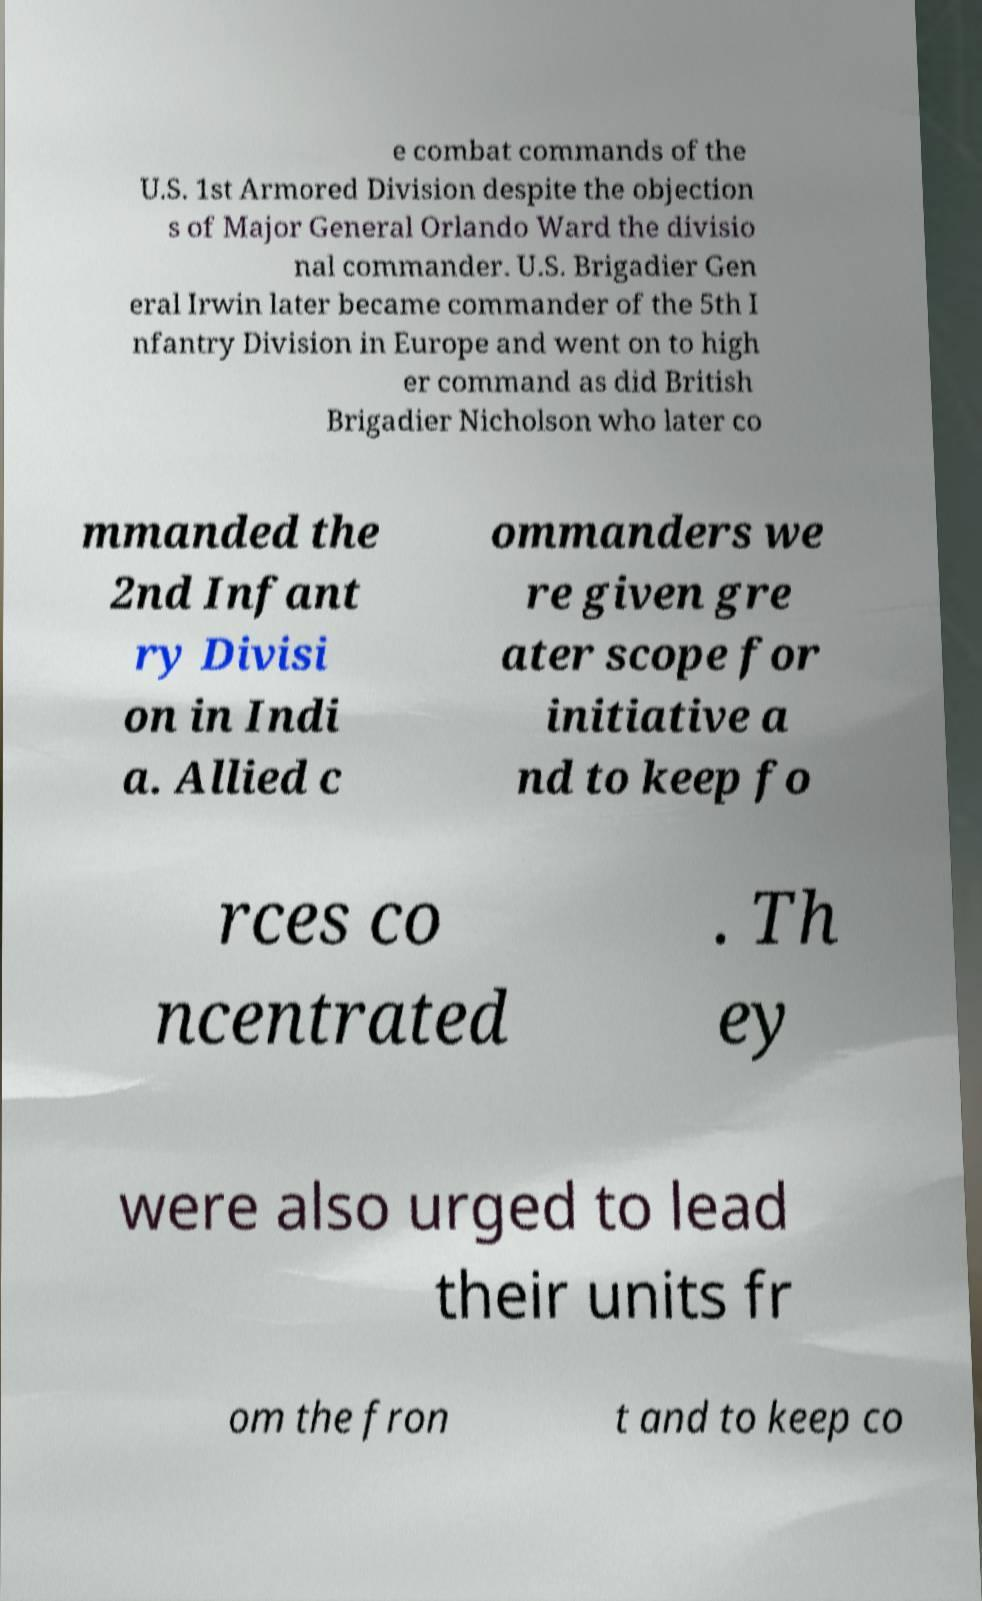I need the written content from this picture converted into text. Can you do that? e combat commands of the U.S. 1st Armored Division despite the objection s of Major General Orlando Ward the divisio nal commander. U.S. Brigadier Gen eral Irwin later became commander of the 5th I nfantry Division in Europe and went on to high er command as did British Brigadier Nicholson who later co mmanded the 2nd Infant ry Divisi on in Indi a. Allied c ommanders we re given gre ater scope for initiative a nd to keep fo rces co ncentrated . Th ey were also urged to lead their units fr om the fron t and to keep co 